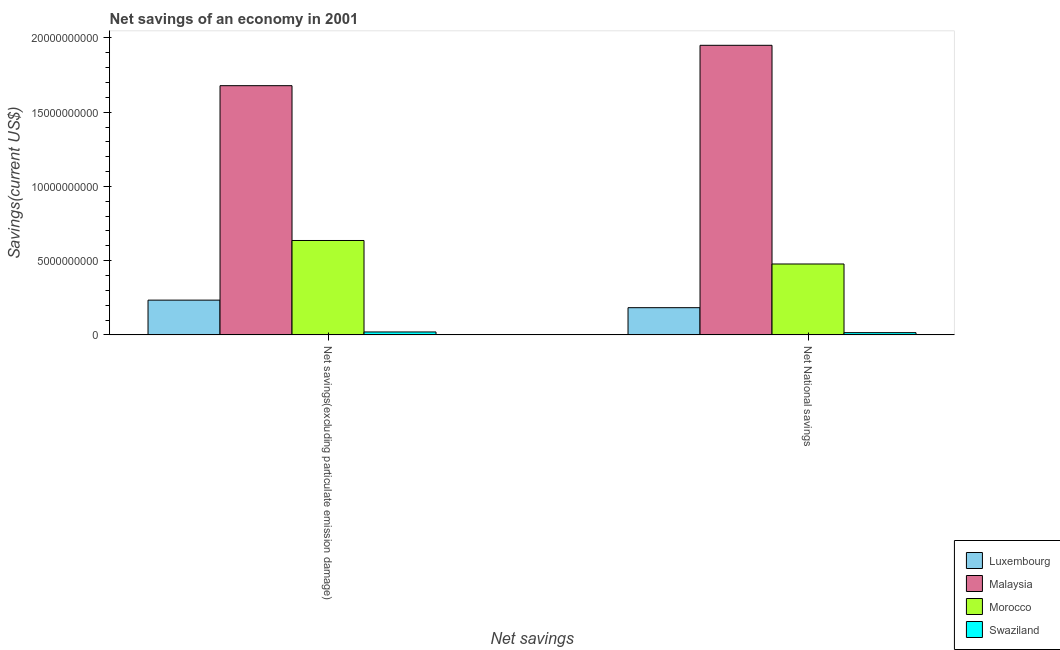How many different coloured bars are there?
Offer a terse response. 4. Are the number of bars per tick equal to the number of legend labels?
Give a very brief answer. Yes. How many bars are there on the 1st tick from the left?
Ensure brevity in your answer.  4. What is the label of the 1st group of bars from the left?
Your response must be concise. Net savings(excluding particulate emission damage). What is the net national savings in Morocco?
Your answer should be very brief. 4.78e+09. Across all countries, what is the maximum net savings(excluding particulate emission damage)?
Give a very brief answer. 1.68e+1. Across all countries, what is the minimum net savings(excluding particulate emission damage)?
Your response must be concise. 1.97e+08. In which country was the net savings(excluding particulate emission damage) maximum?
Make the answer very short. Malaysia. In which country was the net savings(excluding particulate emission damage) minimum?
Provide a succinct answer. Swaziland. What is the total net national savings in the graph?
Make the answer very short. 2.63e+1. What is the difference between the net savings(excluding particulate emission damage) in Luxembourg and that in Morocco?
Provide a succinct answer. -4.02e+09. What is the difference between the net national savings in Swaziland and the net savings(excluding particulate emission damage) in Malaysia?
Make the answer very short. -1.66e+1. What is the average net national savings per country?
Ensure brevity in your answer.  6.57e+09. What is the difference between the net savings(excluding particulate emission damage) and net national savings in Malaysia?
Your answer should be compact. -2.72e+09. What is the ratio of the net national savings in Swaziland to that in Luxembourg?
Your answer should be compact. 0.08. What does the 4th bar from the left in Net National savings represents?
Ensure brevity in your answer.  Swaziland. What does the 2nd bar from the right in Net savings(excluding particulate emission damage) represents?
Your answer should be compact. Morocco. How many bars are there?
Give a very brief answer. 8. How many countries are there in the graph?
Keep it short and to the point. 4. What is the difference between two consecutive major ticks on the Y-axis?
Offer a very short reply. 5.00e+09. Does the graph contain any zero values?
Offer a terse response. No. Does the graph contain grids?
Provide a succinct answer. No. How many legend labels are there?
Your answer should be compact. 4. What is the title of the graph?
Ensure brevity in your answer.  Net savings of an economy in 2001. What is the label or title of the X-axis?
Your response must be concise. Net savings. What is the label or title of the Y-axis?
Ensure brevity in your answer.  Savings(current US$). What is the Savings(current US$) of Luxembourg in Net savings(excluding particulate emission damage)?
Your answer should be very brief. 2.34e+09. What is the Savings(current US$) in Malaysia in Net savings(excluding particulate emission damage)?
Provide a succinct answer. 1.68e+1. What is the Savings(current US$) of Morocco in Net savings(excluding particulate emission damage)?
Keep it short and to the point. 6.36e+09. What is the Savings(current US$) in Swaziland in Net savings(excluding particulate emission damage)?
Your answer should be compact. 1.97e+08. What is the Savings(current US$) in Luxembourg in Net National savings?
Your answer should be very brief. 1.83e+09. What is the Savings(current US$) in Malaysia in Net National savings?
Your answer should be very brief. 1.95e+1. What is the Savings(current US$) in Morocco in Net National savings?
Offer a terse response. 4.78e+09. What is the Savings(current US$) of Swaziland in Net National savings?
Keep it short and to the point. 1.51e+08. Across all Net savings, what is the maximum Savings(current US$) of Luxembourg?
Provide a short and direct response. 2.34e+09. Across all Net savings, what is the maximum Savings(current US$) in Malaysia?
Offer a very short reply. 1.95e+1. Across all Net savings, what is the maximum Savings(current US$) in Morocco?
Provide a short and direct response. 6.36e+09. Across all Net savings, what is the maximum Savings(current US$) of Swaziland?
Offer a very short reply. 1.97e+08. Across all Net savings, what is the minimum Savings(current US$) in Luxembourg?
Provide a succinct answer. 1.83e+09. Across all Net savings, what is the minimum Savings(current US$) in Malaysia?
Provide a short and direct response. 1.68e+1. Across all Net savings, what is the minimum Savings(current US$) of Morocco?
Provide a succinct answer. 4.78e+09. Across all Net savings, what is the minimum Savings(current US$) in Swaziland?
Your response must be concise. 1.51e+08. What is the total Savings(current US$) of Luxembourg in the graph?
Offer a very short reply. 4.17e+09. What is the total Savings(current US$) of Malaysia in the graph?
Your answer should be very brief. 3.63e+1. What is the total Savings(current US$) of Morocco in the graph?
Make the answer very short. 1.11e+1. What is the total Savings(current US$) in Swaziland in the graph?
Your response must be concise. 3.48e+08. What is the difference between the Savings(current US$) of Luxembourg in Net savings(excluding particulate emission damage) and that in Net National savings?
Your answer should be very brief. 5.09e+08. What is the difference between the Savings(current US$) of Malaysia in Net savings(excluding particulate emission damage) and that in Net National savings?
Ensure brevity in your answer.  -2.72e+09. What is the difference between the Savings(current US$) in Morocco in Net savings(excluding particulate emission damage) and that in Net National savings?
Give a very brief answer. 1.58e+09. What is the difference between the Savings(current US$) of Swaziland in Net savings(excluding particulate emission damage) and that in Net National savings?
Keep it short and to the point. 4.64e+07. What is the difference between the Savings(current US$) of Luxembourg in Net savings(excluding particulate emission damage) and the Savings(current US$) of Malaysia in Net National savings?
Provide a succinct answer. -1.72e+1. What is the difference between the Savings(current US$) in Luxembourg in Net savings(excluding particulate emission damage) and the Savings(current US$) in Morocco in Net National savings?
Your answer should be very brief. -2.43e+09. What is the difference between the Savings(current US$) in Luxembourg in Net savings(excluding particulate emission damage) and the Savings(current US$) in Swaziland in Net National savings?
Keep it short and to the point. 2.19e+09. What is the difference between the Savings(current US$) of Malaysia in Net savings(excluding particulate emission damage) and the Savings(current US$) of Morocco in Net National savings?
Provide a short and direct response. 1.20e+1. What is the difference between the Savings(current US$) in Malaysia in Net savings(excluding particulate emission damage) and the Savings(current US$) in Swaziland in Net National savings?
Your response must be concise. 1.66e+1. What is the difference between the Savings(current US$) in Morocco in Net savings(excluding particulate emission damage) and the Savings(current US$) in Swaziland in Net National savings?
Provide a short and direct response. 6.21e+09. What is the average Savings(current US$) in Luxembourg per Net savings?
Keep it short and to the point. 2.09e+09. What is the average Savings(current US$) in Malaysia per Net savings?
Give a very brief answer. 1.81e+1. What is the average Savings(current US$) of Morocco per Net savings?
Make the answer very short. 5.57e+09. What is the average Savings(current US$) of Swaziland per Net savings?
Your answer should be very brief. 1.74e+08. What is the difference between the Savings(current US$) of Luxembourg and Savings(current US$) of Malaysia in Net savings(excluding particulate emission damage)?
Your answer should be very brief. -1.44e+1. What is the difference between the Savings(current US$) of Luxembourg and Savings(current US$) of Morocco in Net savings(excluding particulate emission damage)?
Ensure brevity in your answer.  -4.02e+09. What is the difference between the Savings(current US$) of Luxembourg and Savings(current US$) of Swaziland in Net savings(excluding particulate emission damage)?
Ensure brevity in your answer.  2.14e+09. What is the difference between the Savings(current US$) of Malaysia and Savings(current US$) of Morocco in Net savings(excluding particulate emission damage)?
Your answer should be very brief. 1.04e+1. What is the difference between the Savings(current US$) in Malaysia and Savings(current US$) in Swaziland in Net savings(excluding particulate emission damage)?
Your answer should be very brief. 1.66e+1. What is the difference between the Savings(current US$) of Morocco and Savings(current US$) of Swaziland in Net savings(excluding particulate emission damage)?
Your answer should be very brief. 6.16e+09. What is the difference between the Savings(current US$) of Luxembourg and Savings(current US$) of Malaysia in Net National savings?
Your answer should be very brief. -1.77e+1. What is the difference between the Savings(current US$) of Luxembourg and Savings(current US$) of Morocco in Net National savings?
Provide a short and direct response. -2.94e+09. What is the difference between the Savings(current US$) of Luxembourg and Savings(current US$) of Swaziland in Net National savings?
Offer a very short reply. 1.68e+09. What is the difference between the Savings(current US$) of Malaysia and Savings(current US$) of Morocco in Net National savings?
Provide a short and direct response. 1.47e+1. What is the difference between the Savings(current US$) of Malaysia and Savings(current US$) of Swaziland in Net National savings?
Your answer should be compact. 1.94e+1. What is the difference between the Savings(current US$) in Morocco and Savings(current US$) in Swaziland in Net National savings?
Offer a terse response. 4.63e+09. What is the ratio of the Savings(current US$) in Luxembourg in Net savings(excluding particulate emission damage) to that in Net National savings?
Make the answer very short. 1.28. What is the ratio of the Savings(current US$) in Malaysia in Net savings(excluding particulate emission damage) to that in Net National savings?
Give a very brief answer. 0.86. What is the ratio of the Savings(current US$) of Morocco in Net savings(excluding particulate emission damage) to that in Net National savings?
Your answer should be compact. 1.33. What is the ratio of the Savings(current US$) in Swaziland in Net savings(excluding particulate emission damage) to that in Net National savings?
Ensure brevity in your answer.  1.31. What is the difference between the highest and the second highest Savings(current US$) in Luxembourg?
Give a very brief answer. 5.09e+08. What is the difference between the highest and the second highest Savings(current US$) in Malaysia?
Offer a terse response. 2.72e+09. What is the difference between the highest and the second highest Savings(current US$) in Morocco?
Your answer should be compact. 1.58e+09. What is the difference between the highest and the second highest Savings(current US$) of Swaziland?
Give a very brief answer. 4.64e+07. What is the difference between the highest and the lowest Savings(current US$) of Luxembourg?
Your answer should be very brief. 5.09e+08. What is the difference between the highest and the lowest Savings(current US$) of Malaysia?
Keep it short and to the point. 2.72e+09. What is the difference between the highest and the lowest Savings(current US$) of Morocco?
Your response must be concise. 1.58e+09. What is the difference between the highest and the lowest Savings(current US$) of Swaziland?
Keep it short and to the point. 4.64e+07. 